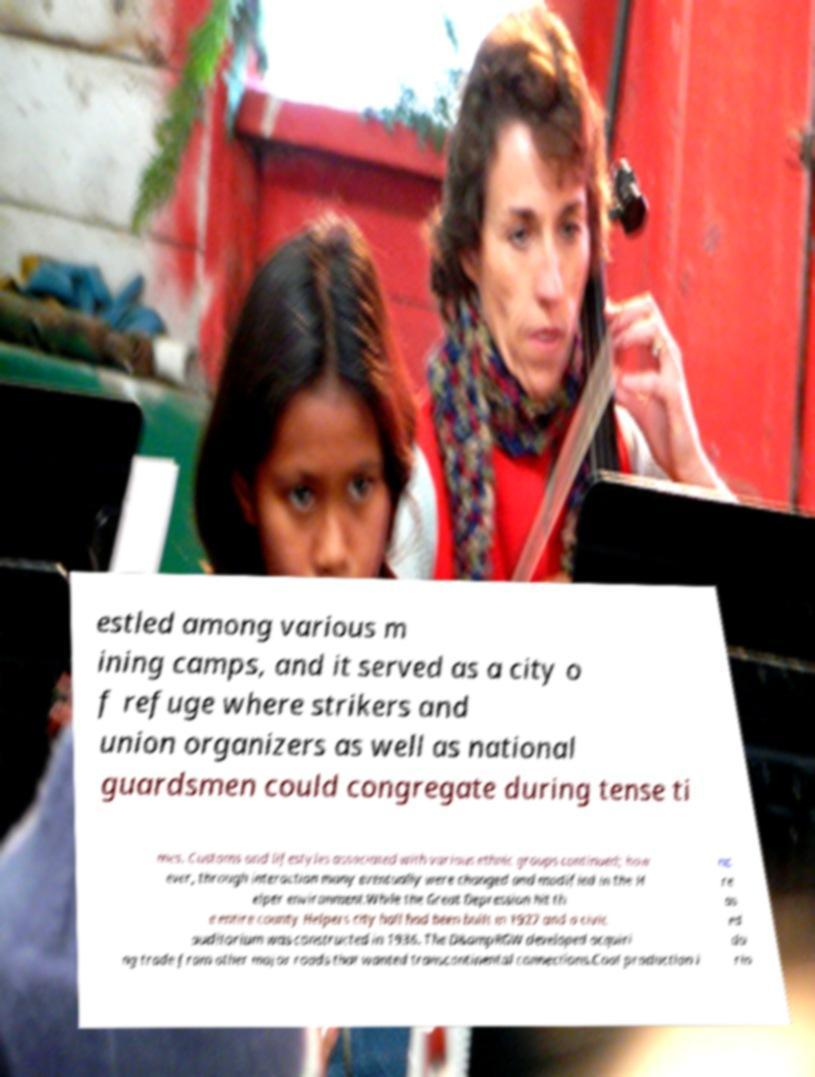Can you read and provide the text displayed in the image?This photo seems to have some interesting text. Can you extract and type it out for me? estled among various m ining camps, and it served as a city o f refuge where strikers and union organizers as well as national guardsmen could congregate during tense ti mes. Customs and lifestyles associated with various ethnic groups continued; how ever, through interaction many eventually were changed and modified in the H elper environment.While the Great Depression hit th e entire county Helpers city hall had been built in 1927 and a civic auditorium was constructed in 1936. The D&ampRGW developed acquiri ng trade from other major roads that wanted transcontinental connections.Coal production i nc re as ed du rin 